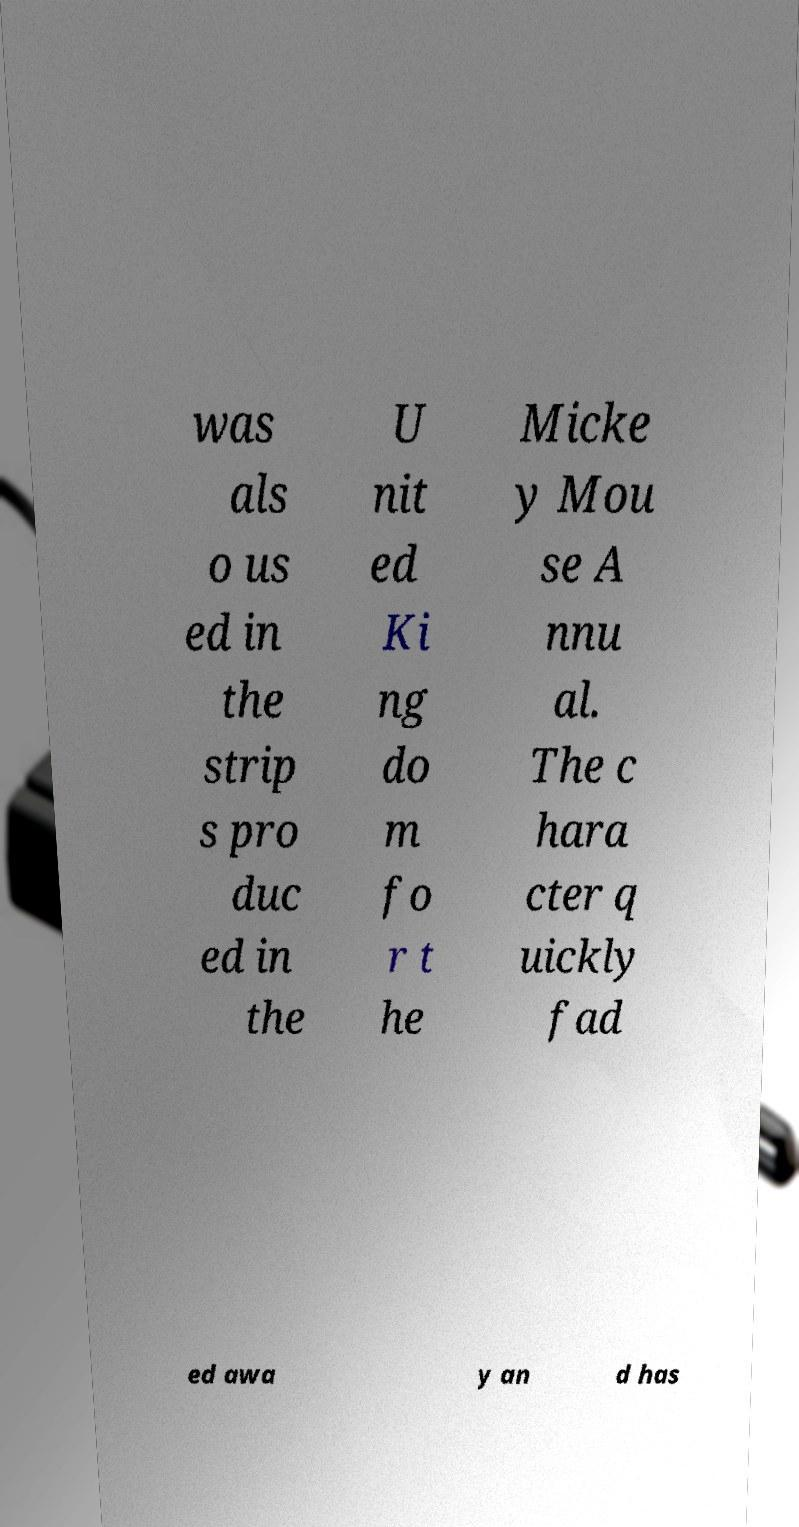Please read and relay the text visible in this image. What does it say? was als o us ed in the strip s pro duc ed in the U nit ed Ki ng do m fo r t he Micke y Mou se A nnu al. The c hara cter q uickly fad ed awa y an d has 